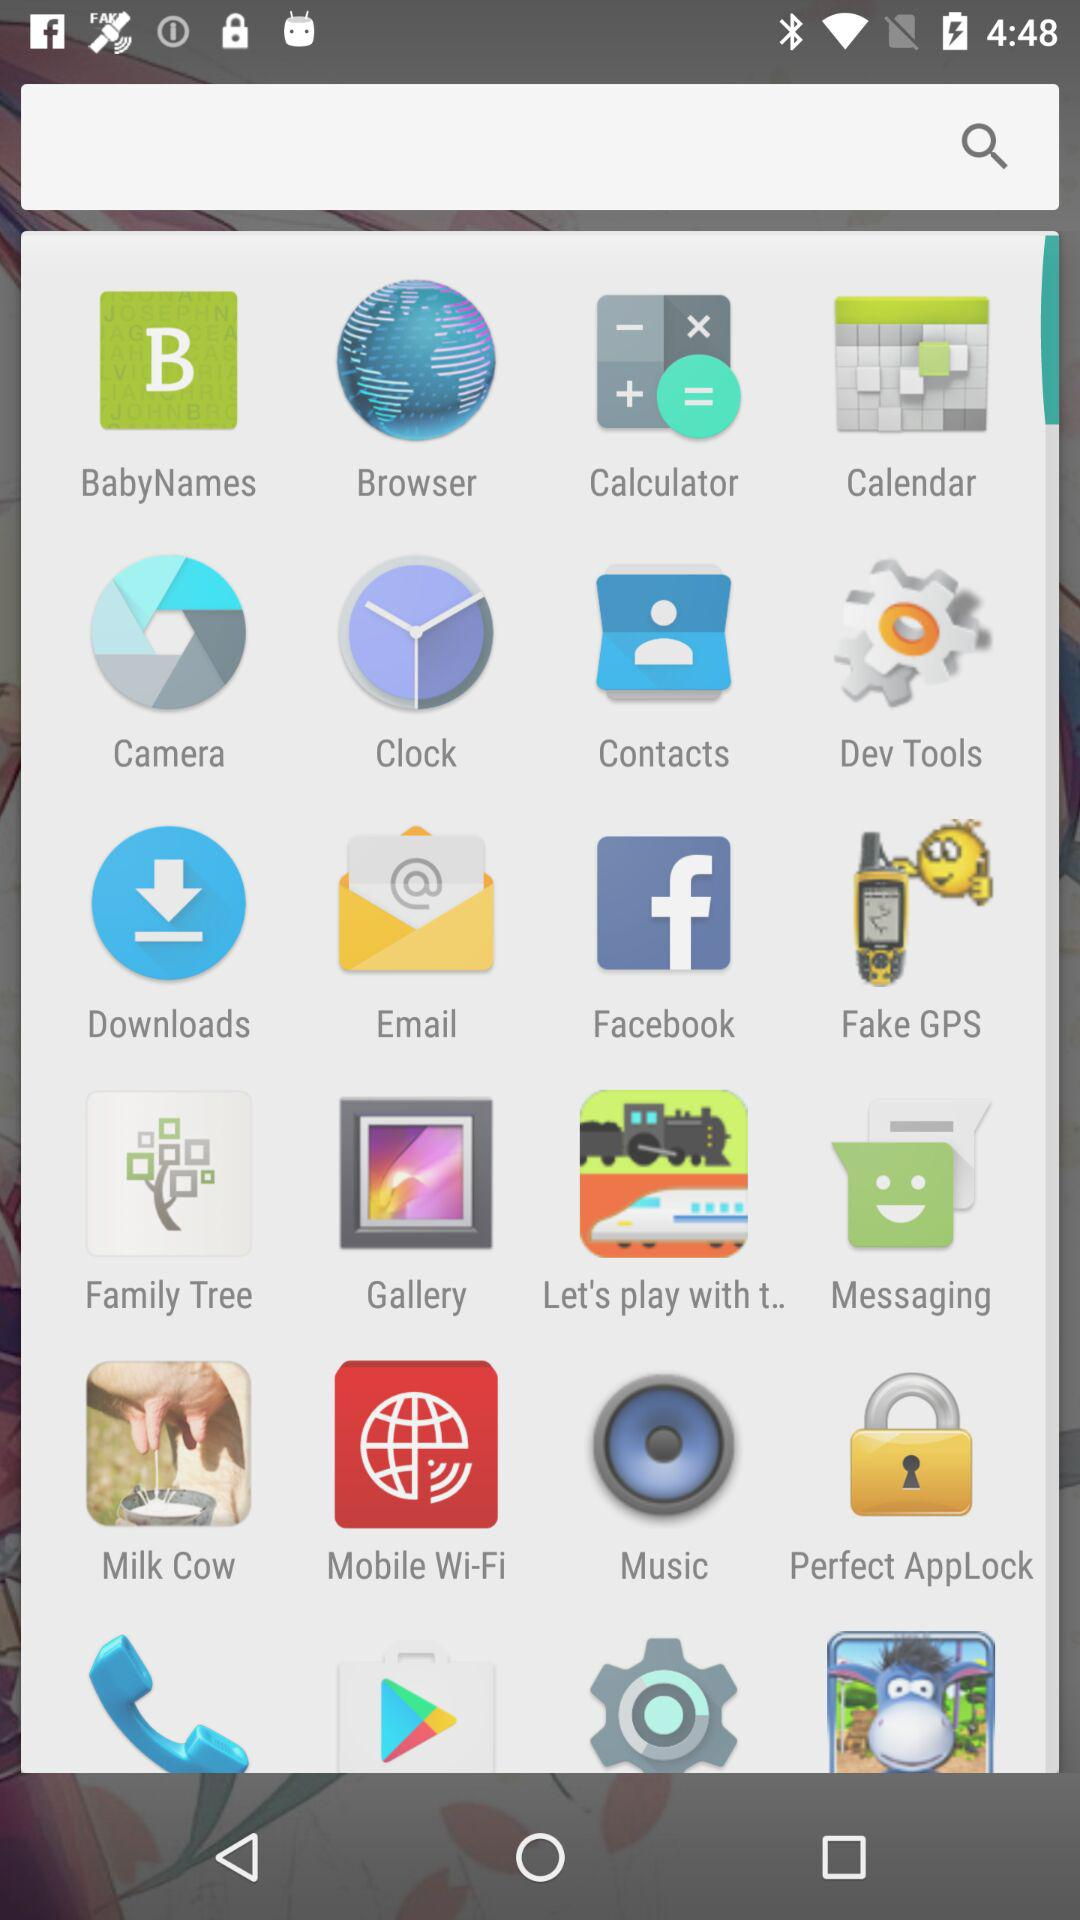What is the score?
When the provided information is insufficient, respond with <no answer>. <no answer> 